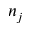Convert formula to latex. <formula><loc_0><loc_0><loc_500><loc_500>n _ { j }</formula> 